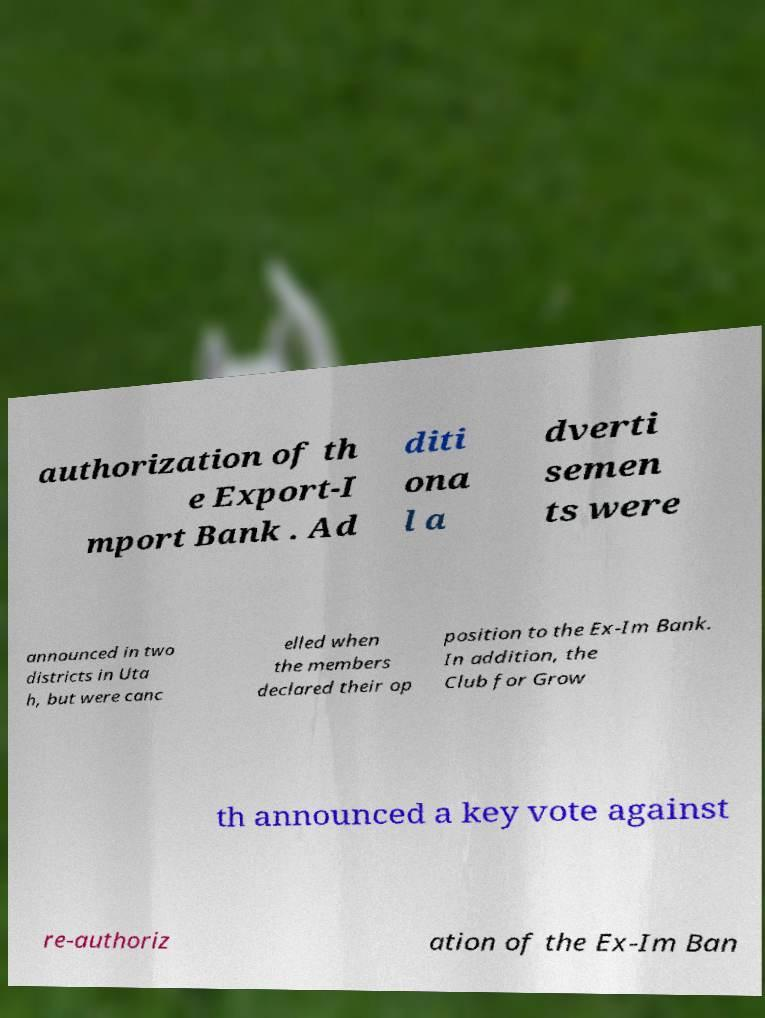Please identify and transcribe the text found in this image. authorization of th e Export-I mport Bank . Ad diti ona l a dverti semen ts were announced in two districts in Uta h, but were canc elled when the members declared their op position to the Ex-Im Bank. In addition, the Club for Grow th announced a key vote against re-authoriz ation of the Ex-Im Ban 